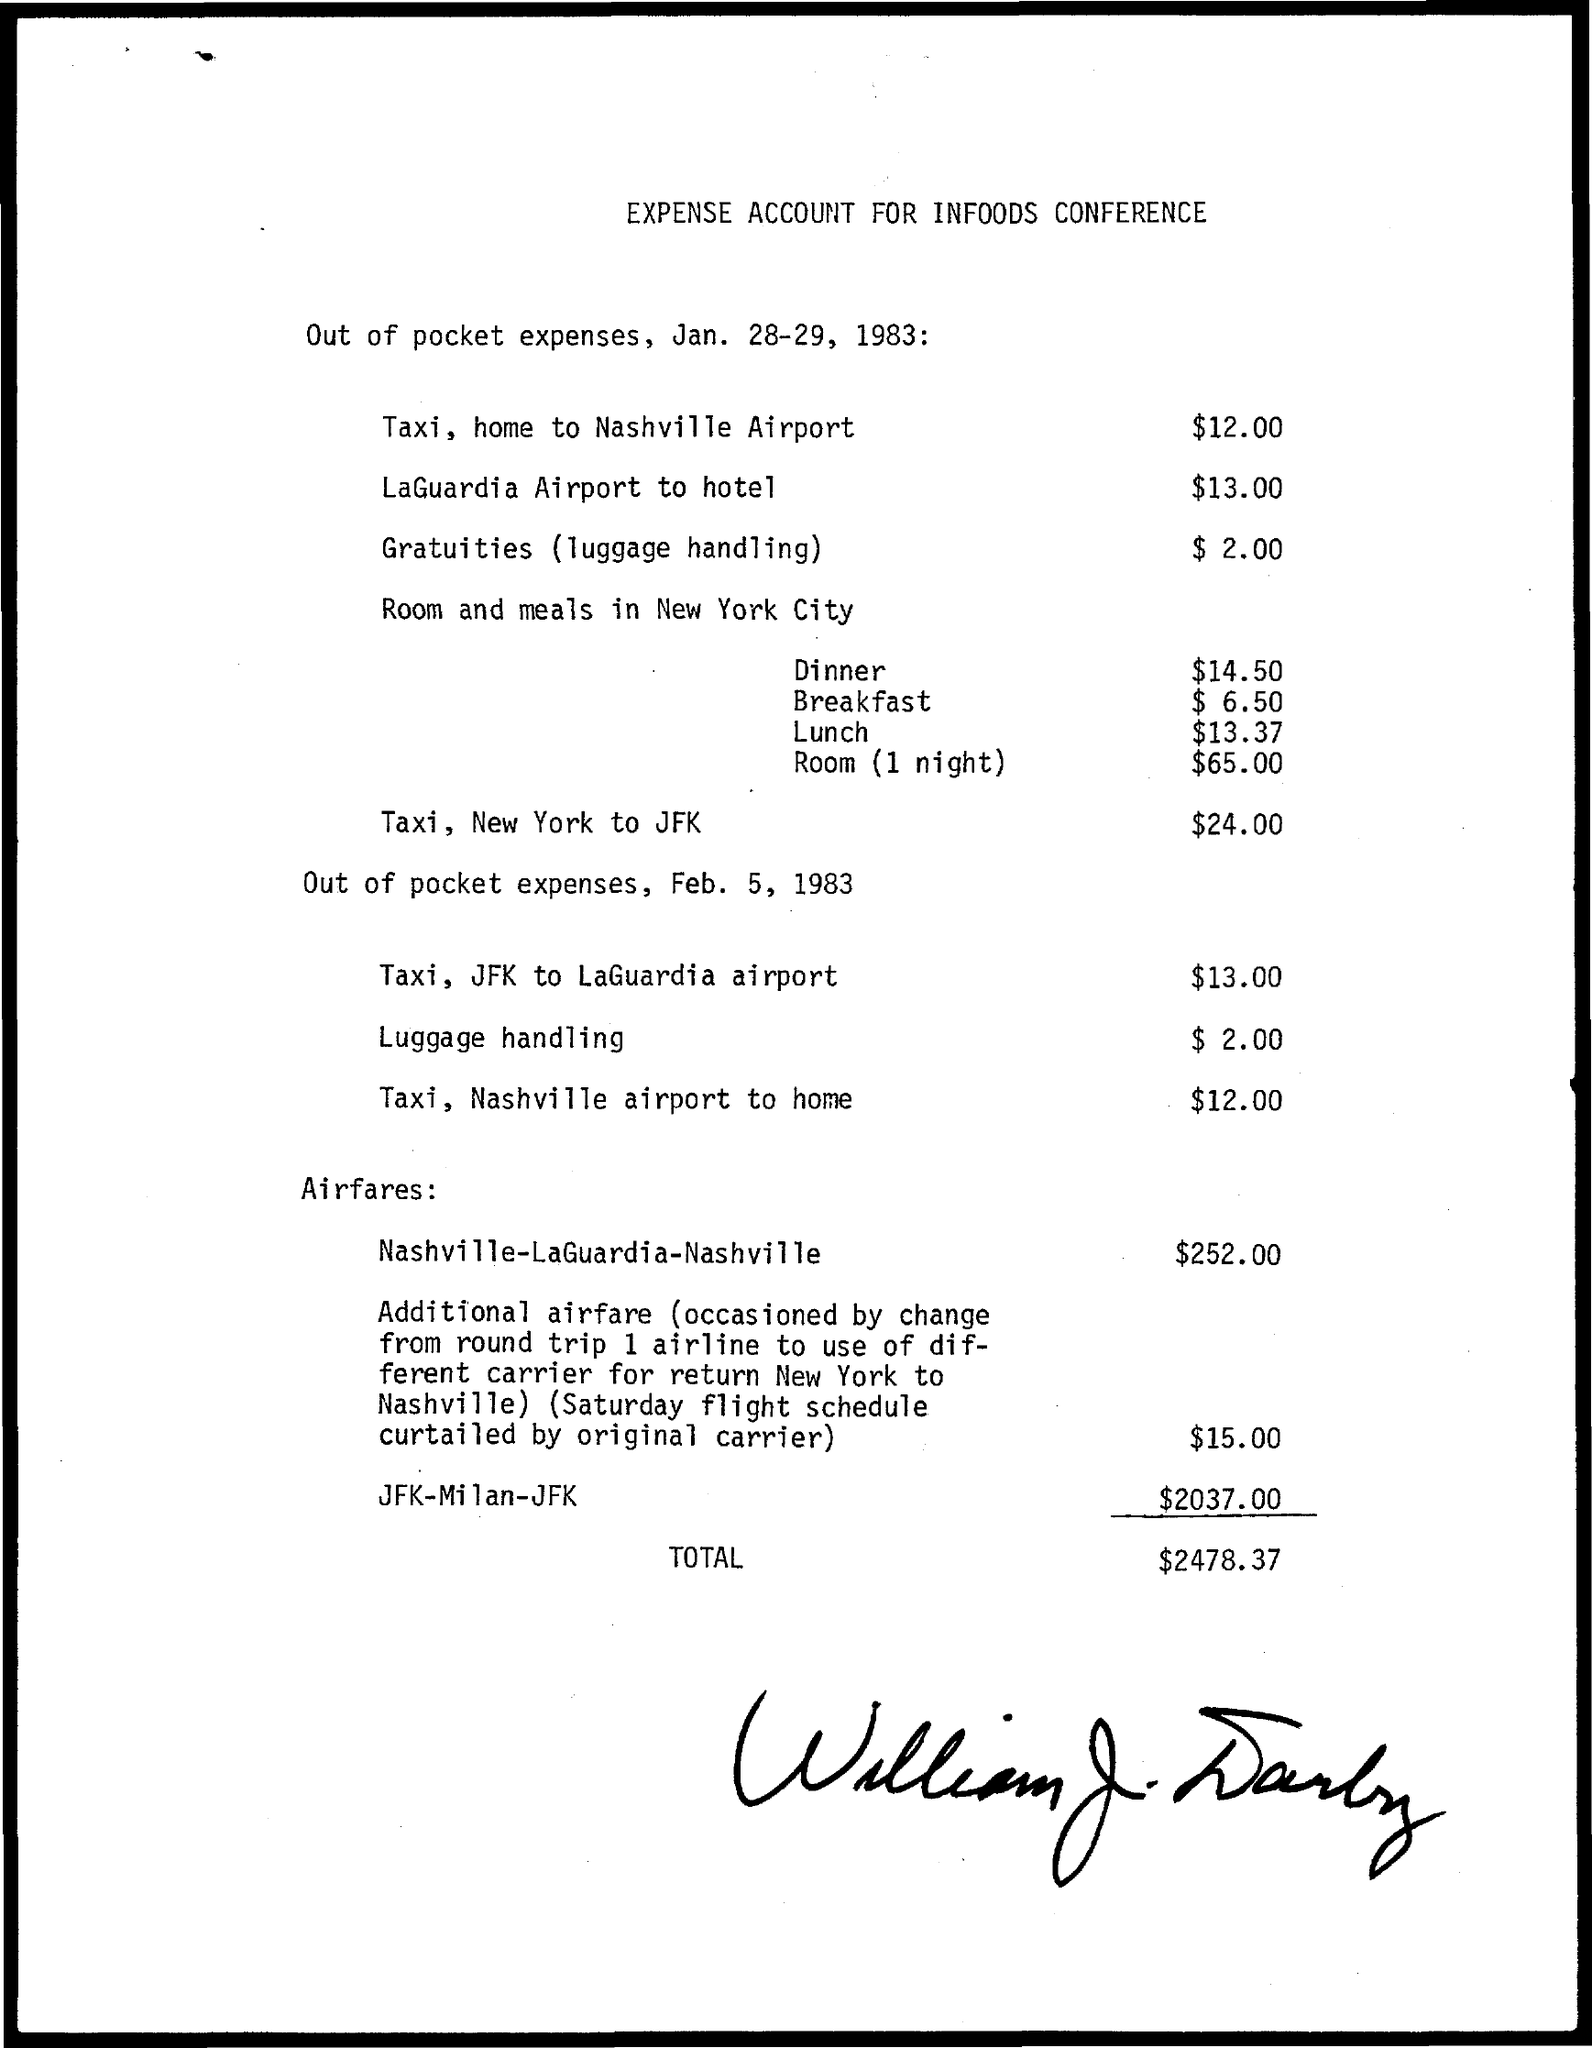Identify some key points in this picture. The document is titled 'Expense Account for Infoods Conference.' The expense for a taxi from JFK Airport to LaGuardia Airport is $13.00. The total amount is $2478.37. The expense for gratuities, including luggage handling, is $2.00. The expense for traveling from LaGuardia Airport to a hotel is $13.00. 